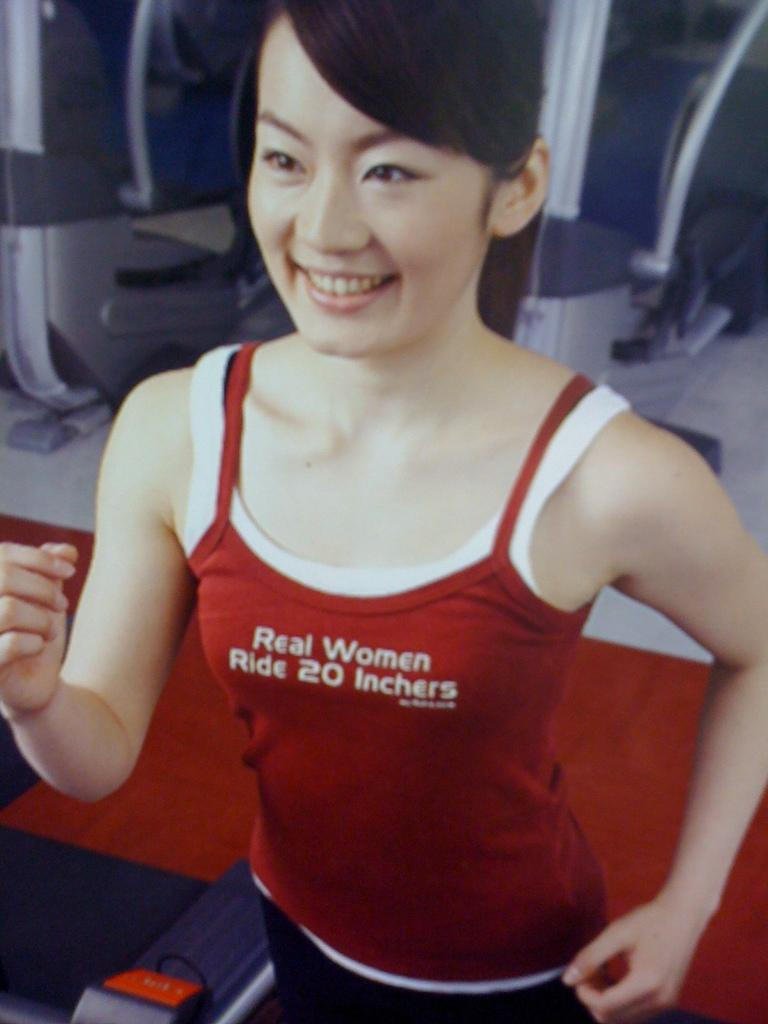<image>
Summarize the visual content of the image. A woman on a treadmill wears a shirt that implies that real women ride large objects. 